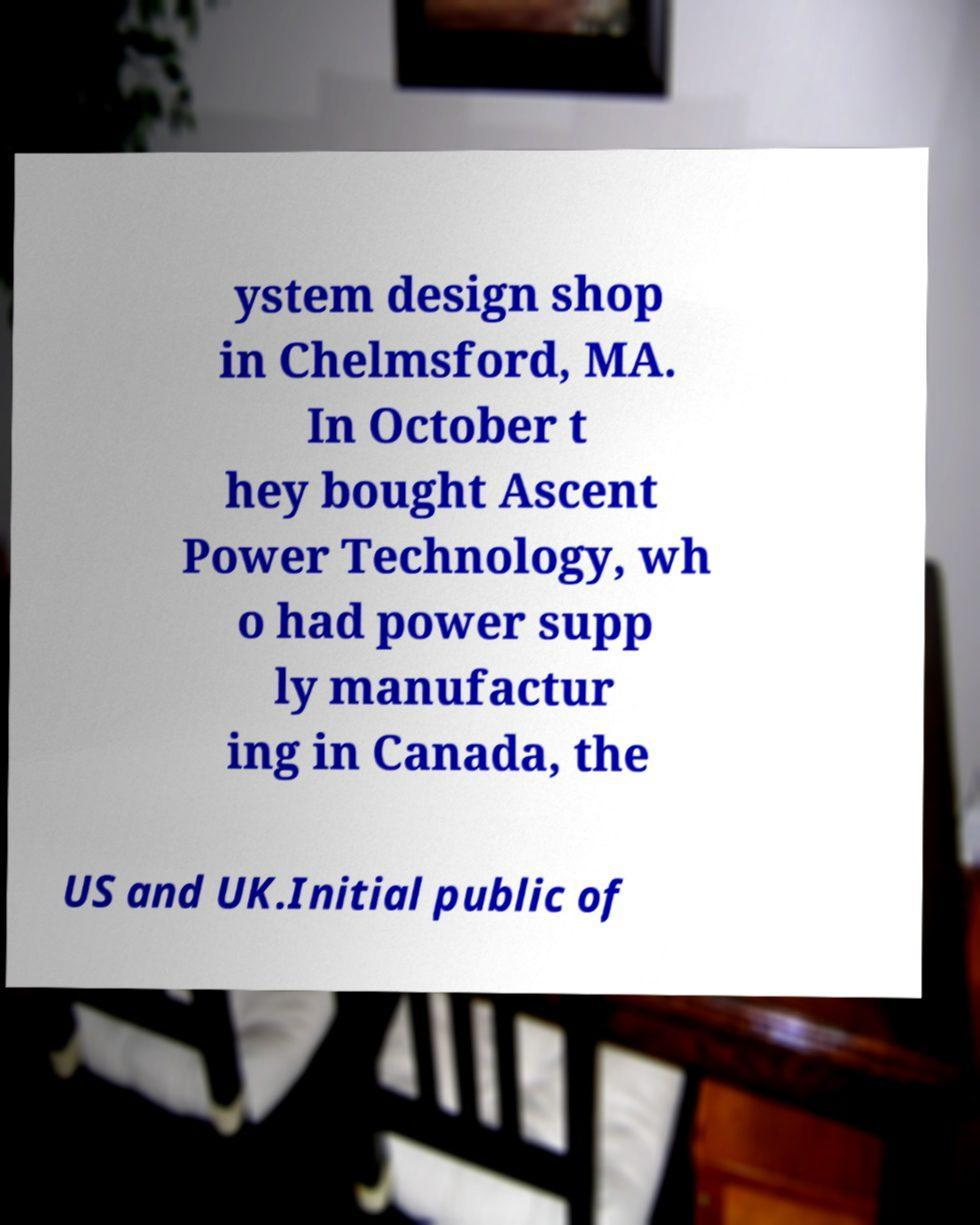What messages or text are displayed in this image? I need them in a readable, typed format. ystem design shop in Chelmsford, MA. In October t hey bought Ascent Power Technology, wh o had power supp ly manufactur ing in Canada, the US and UK.Initial public of 